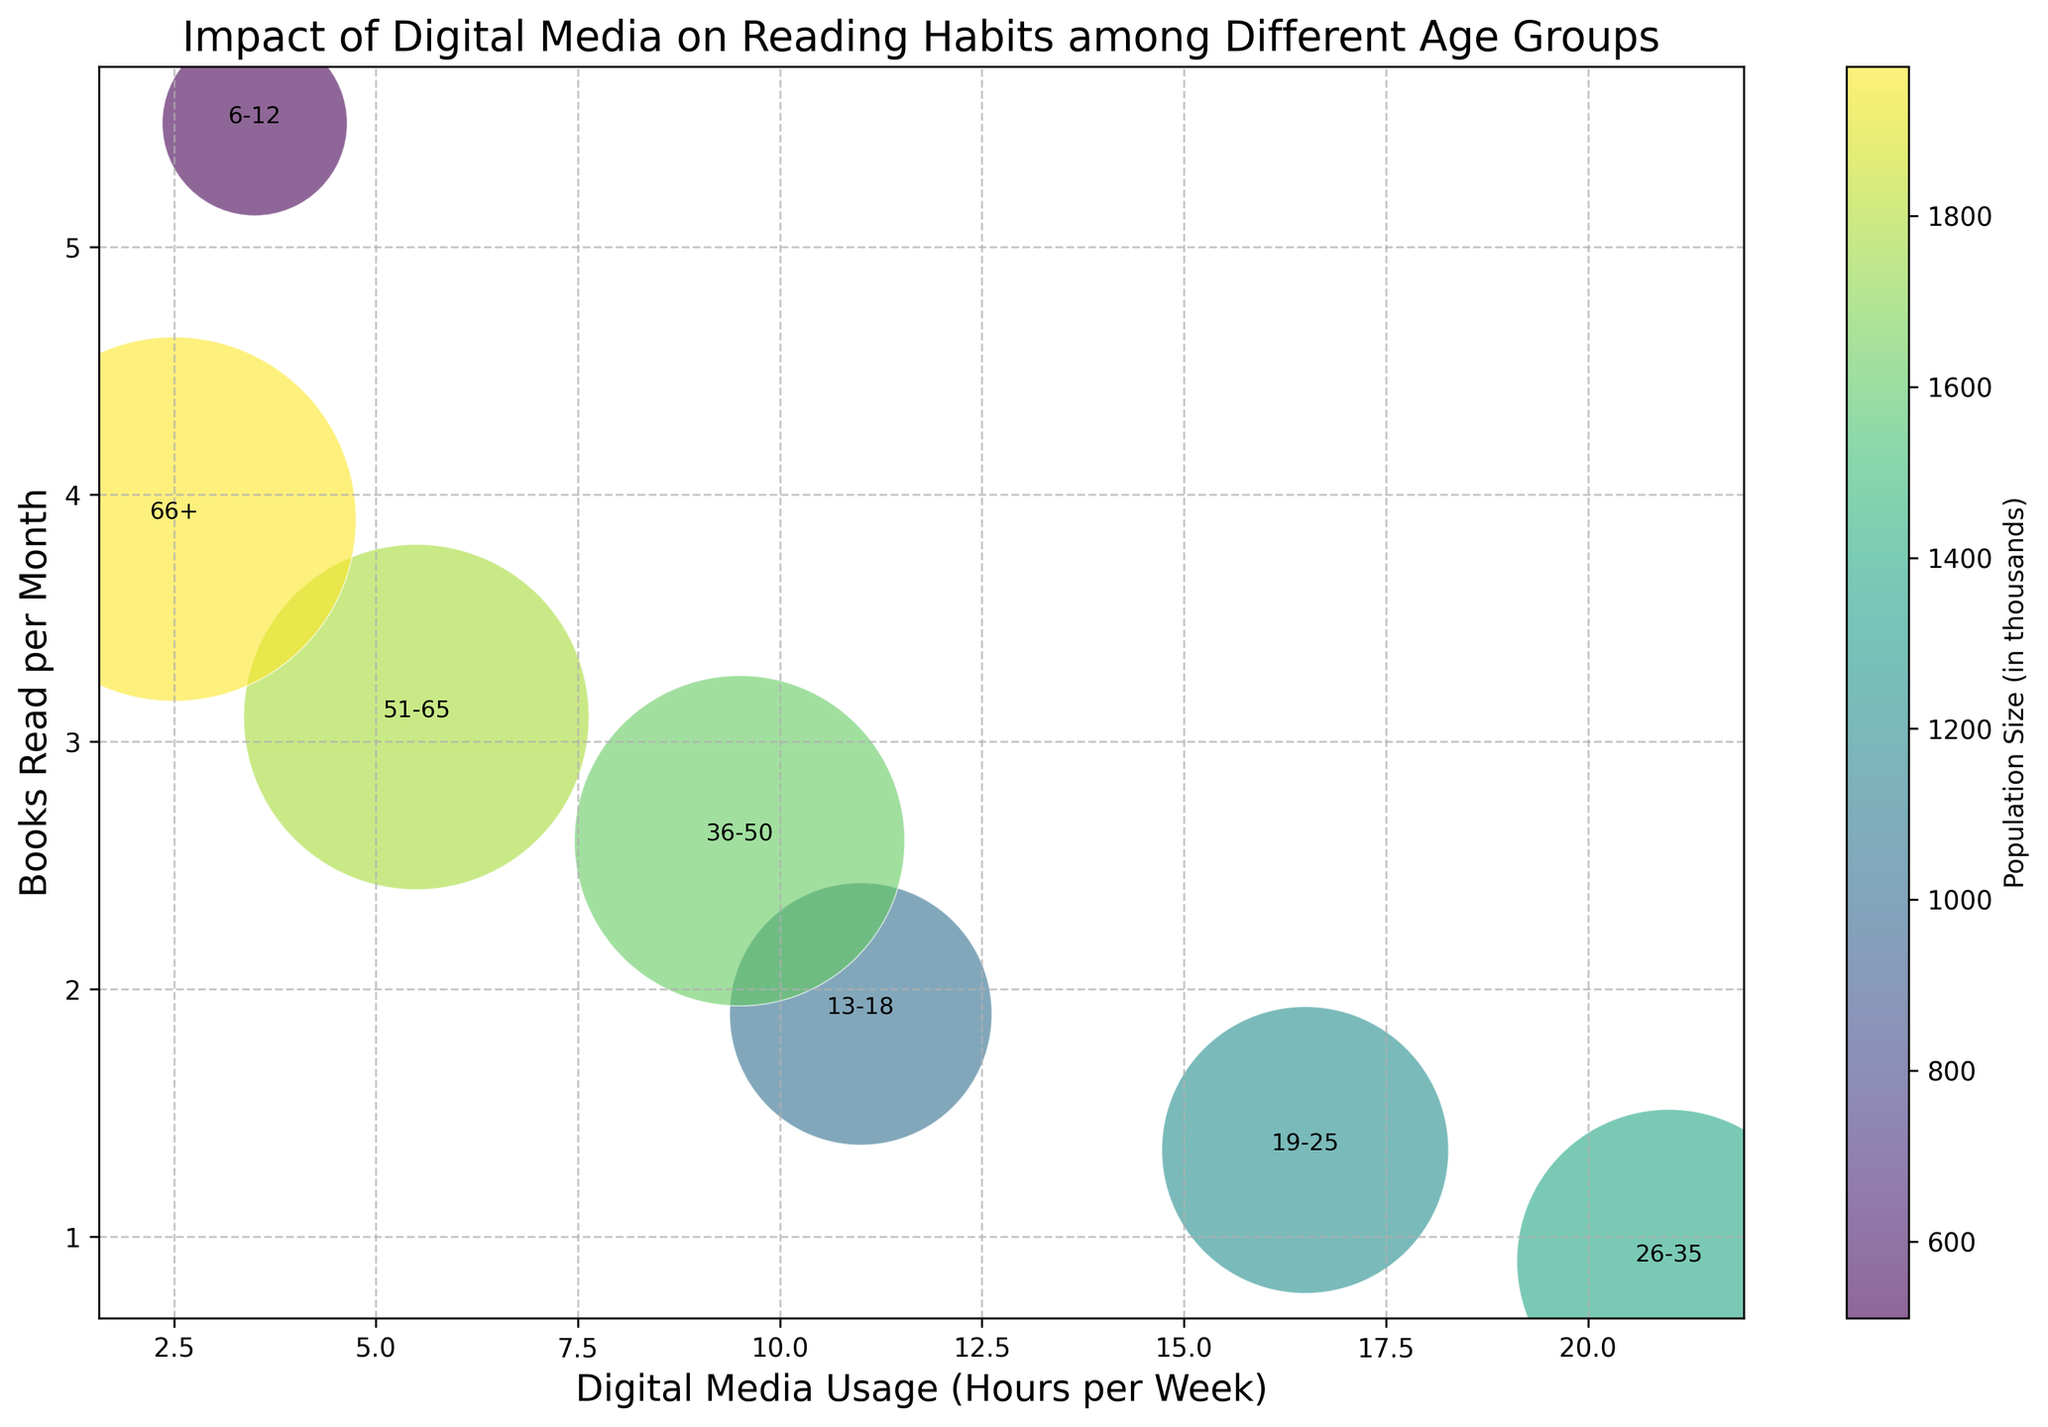Which age group has the highest average digital media usage per week? Looking at the 'Digital Media Usage (Hours per Week)' on the x-axis, the age group with the highest average usage appears at the rightmost position. The age group '26-35' is plotted furthest to the right, indicating it has the highest digital media usage.
Answer: 26-35 Which age group reads the least number of books per month on average? Looking at the 'Books Read per Month' on the y-axis, the group with the lowest value will be closest to the bottom of the chart. The age group '26-35' is positioned lowest, indicating it reads the fewest number of books.
Answer: 26-35 What is the relationship between digital media usage and books read for the 19-25 age group? The '19-25' group can be found by identifying its label on the chart. It is situated with a relatively high digital media usage (farther right) and a low number of books read per month (nearer the bottom). This indicates an inverse relationship between digital media usage and books read for this age group.
Answer: Inversely related Which age group has the largest population size, and how is it represented on the chart? To find the age group with the largest population, refer to the size of the bubbles. The largest bubble represents the '66+' age group, and is indicated by the plot size and color.
Answer: 66+ Which two age groups have an equal number of books read per month but different digital media usage? Looking at the 'Books Read per Month' on the y-axis, identify pairs of groups that are horizontally aligned, then compare their digital media usage on the x-axis. The '13-18' and '36-50' age groups both read around 2 books per month but differ in their digital media usage (10 vs. 10 hours respectively).
Answer: 13-18 and 36-50 How does digital media usage compare between the age groups 6-12 and 66+? Locate the bubbles labeled '6-12' and '66+', and compare their positions on the x-axis. The '6-12' age group is further to the right, indicating higher digital media usage than the '66+' group.
Answer: 6-12 uses more digital media than 66+ Which age group shows a balance of moderate digital media usage and a relatively high number of books read per month? Identifying a group with moderate digital media usage and relatively high books read, examine the mid-section of the x-axis and the higher position of the y-axis. The '36-50' age group stands out as having a balance between digital media usage (around 10 hours) and reading books (approximately 2.7 books).
Answer: 36-50 How many more books per month does the 6-12 age group read compared to the 26-35 age group? Identify the y-axis values for both groups and subtract the lower from the higher. '6-12' reads around 5.5 books per month, and '26-35' reads around 0.9 books per month. The difference is 5.5 - 0.9.
Answer: 4.6 more books Which age groups have digital media usage greater than 10 hours per week? Scan along the x-axis, identifying all bubbles beyond the 10-hour mark. The age groups '13-18', '19-25', '26-35' all have digital media usage greater than 10 hours per week.
Answer: 13-18, 19-25, 26-35 What is the general trend between digital media usage and books read across all age groups? Observing the overall distribution of bubbles, there seems to be a trend where higher digital media usage corresponds with fewer books read per month and vice versa, indicating an inverse relationship.
Answer: Inverse relationship 